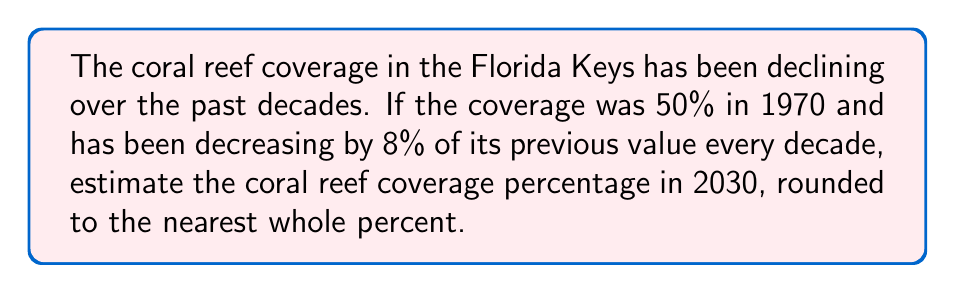Show me your answer to this math problem. Let's approach this step-by-step:

1) We start with 50% coverage in 1970.

2) Each decade, the coverage decreases by 8% of its previous value. This means we multiply the previous value by 0.92 (1 - 0.08 = 0.92) for each decade.

3) From 1970 to 2030, there are 6 decades. So we need to multiply by 0.92 six times.

4) Mathematically, this can be expressed as:

   $$ 50 \times (0.92)^6 $$

5) Let's calculate this:
   $$ 50 \times (0.92)^6 = 50 \times 0.6047 = 30.235 $$

6) Rounding to the nearest whole percent gives us 30%.

This calculation shows the estimated coral reef coverage in the Florida Keys will be approximately 30% in 2030 if the current rate of decline continues.
Answer: 30% 